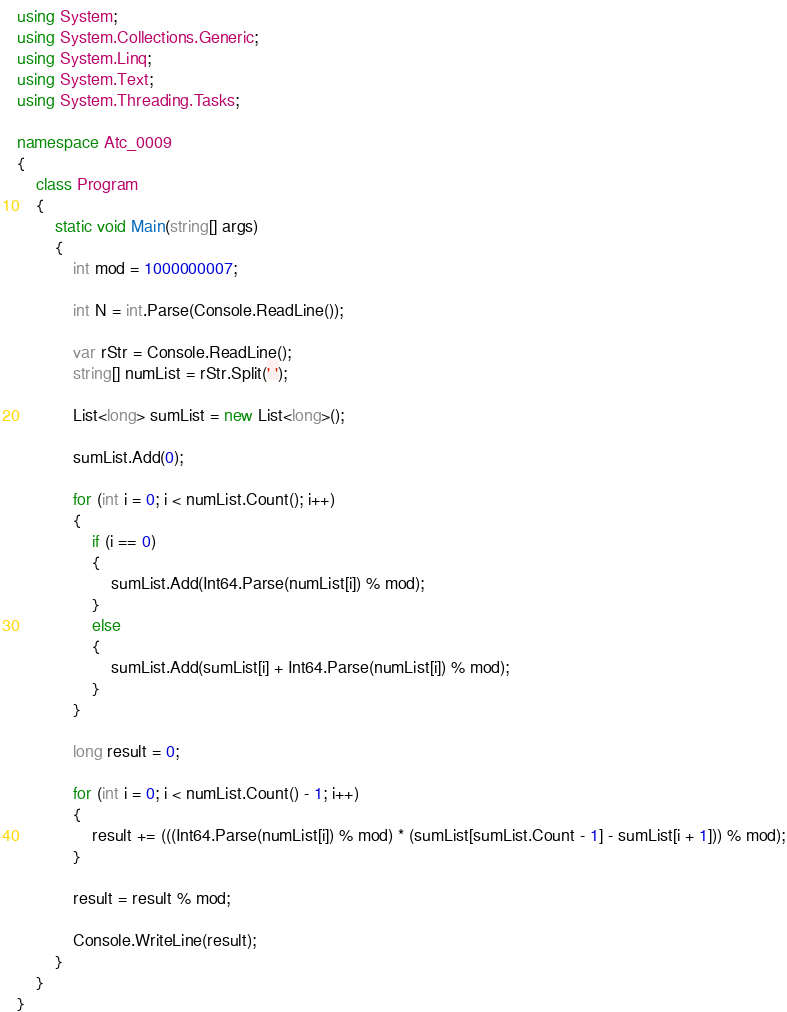Convert code to text. <code><loc_0><loc_0><loc_500><loc_500><_C#_>using System;
using System.Collections.Generic;
using System.Linq;
using System.Text;
using System.Threading.Tasks;

namespace Atc_0009
{
    class Program
    {
        static void Main(string[] args)
        {
            int mod = 1000000007;

            int N = int.Parse(Console.ReadLine());

            var rStr = Console.ReadLine();
            string[] numList = rStr.Split(' ');

            List<long> sumList = new List<long>();

            sumList.Add(0);

            for (int i = 0; i < numList.Count(); i++)
            {
                if (i == 0)
                {
                    sumList.Add(Int64.Parse(numList[i]) % mod);
                }
                else
                {
                    sumList.Add(sumList[i] + Int64.Parse(numList[i]) % mod);
                }
            }

            long result = 0;

            for (int i = 0; i < numList.Count() - 1; i++)
            {
                result += (((Int64.Parse(numList[i]) % mod) * (sumList[sumList.Count - 1] - sumList[i + 1])) % mod);
            }

            result = result % mod;

            Console.WriteLine(result);
        }
    }
}
</code> 